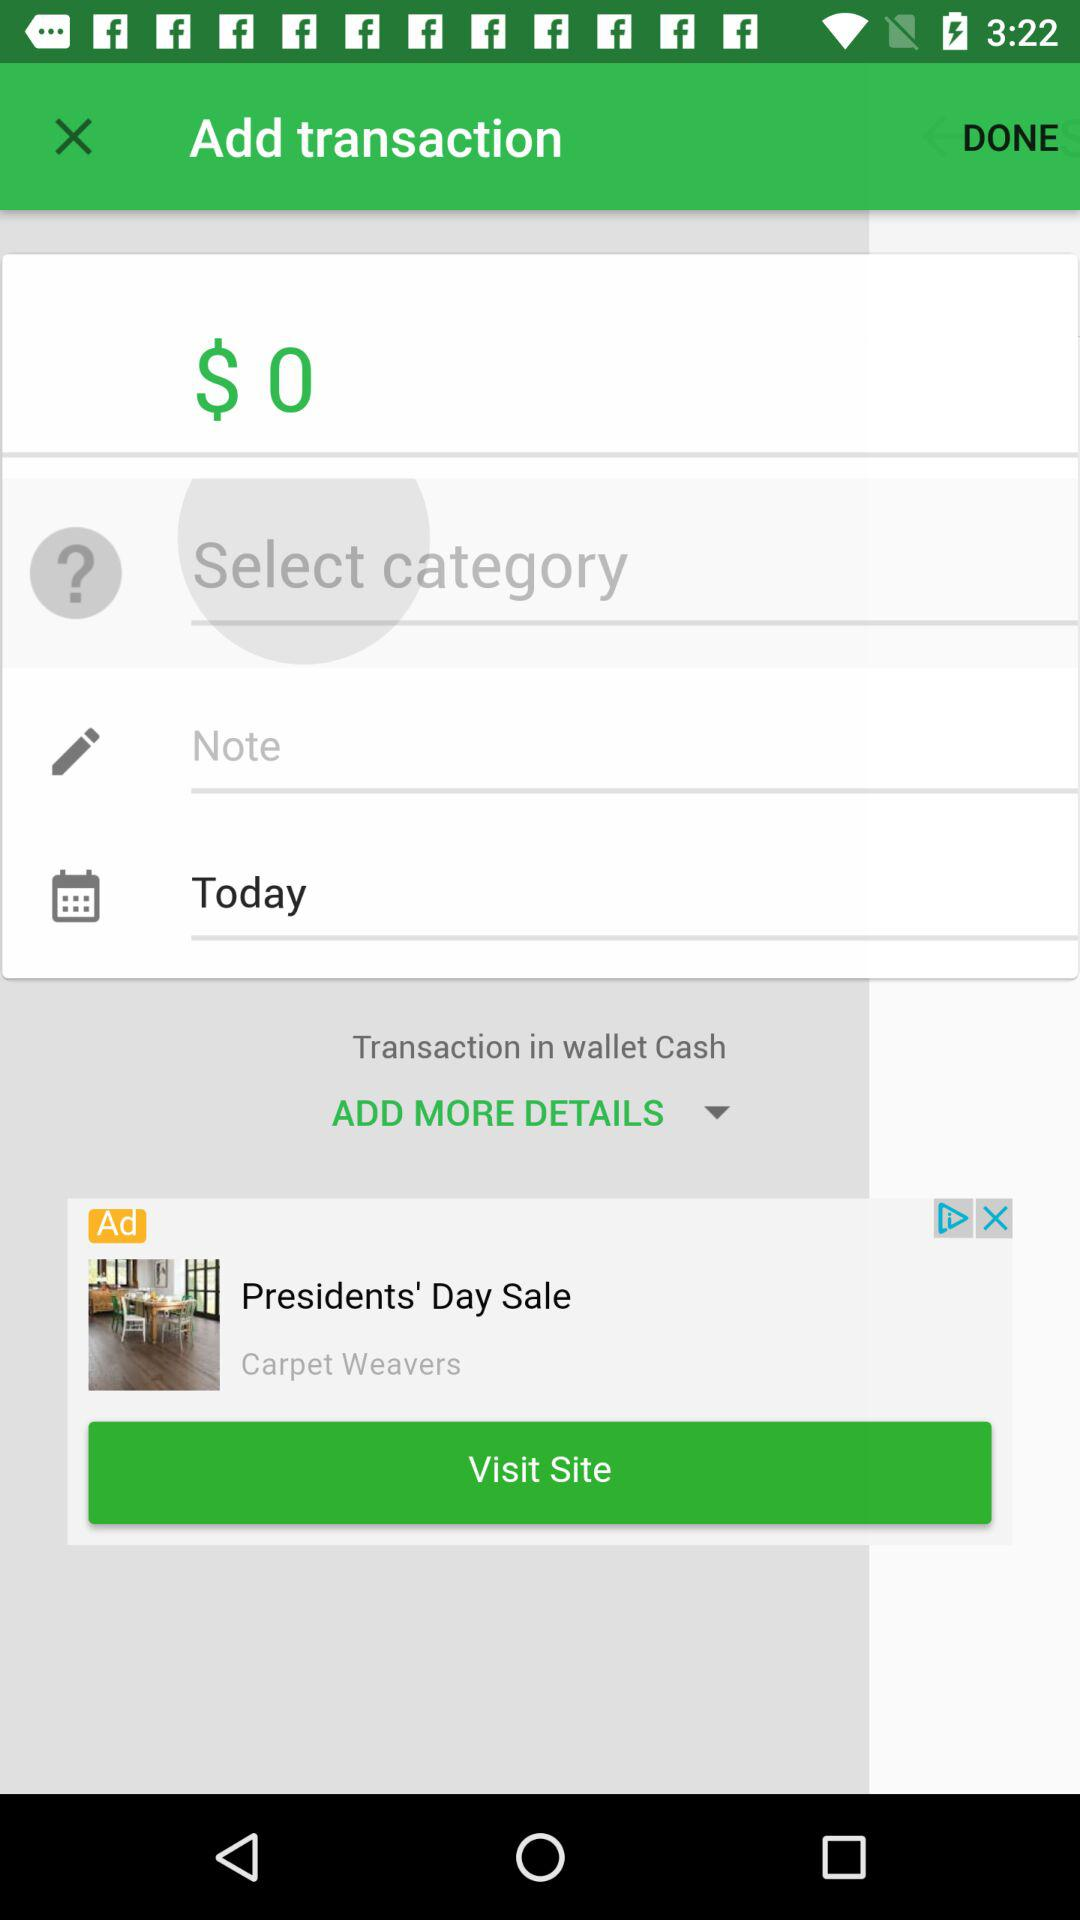How much is the amount of the transaction?
Answer the question using a single word or phrase. $0 